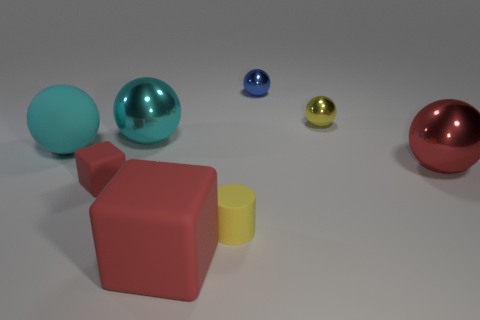What is the size of the red rubber object on the right side of the large cyan metal ball?
Make the answer very short. Large. What is the shape of the big metallic thing that is the same color as the large rubber sphere?
Your answer should be very brief. Sphere. Do the red ball and the block that is on the left side of the large cyan shiny thing have the same material?
Your answer should be very brief. No. How many red blocks are to the right of the big red thing that is in front of the thing that is right of the yellow metallic object?
Offer a terse response. 0. What number of blue things are either large metal objects or small spheres?
Provide a succinct answer. 1. There is a object that is behind the small yellow sphere; what is its shape?
Offer a very short reply. Sphere. What color is the matte cube that is the same size as the yellow rubber thing?
Your answer should be compact. Red. There is a cyan rubber object; does it have the same shape as the large red object to the left of the blue metal thing?
Provide a succinct answer. No. There is a yellow thing behind the yellow thing in front of the large sphere on the right side of the blue metal ball; what is it made of?
Provide a short and direct response. Metal. What number of small objects are either red matte cylinders or red shiny balls?
Provide a succinct answer. 0. 